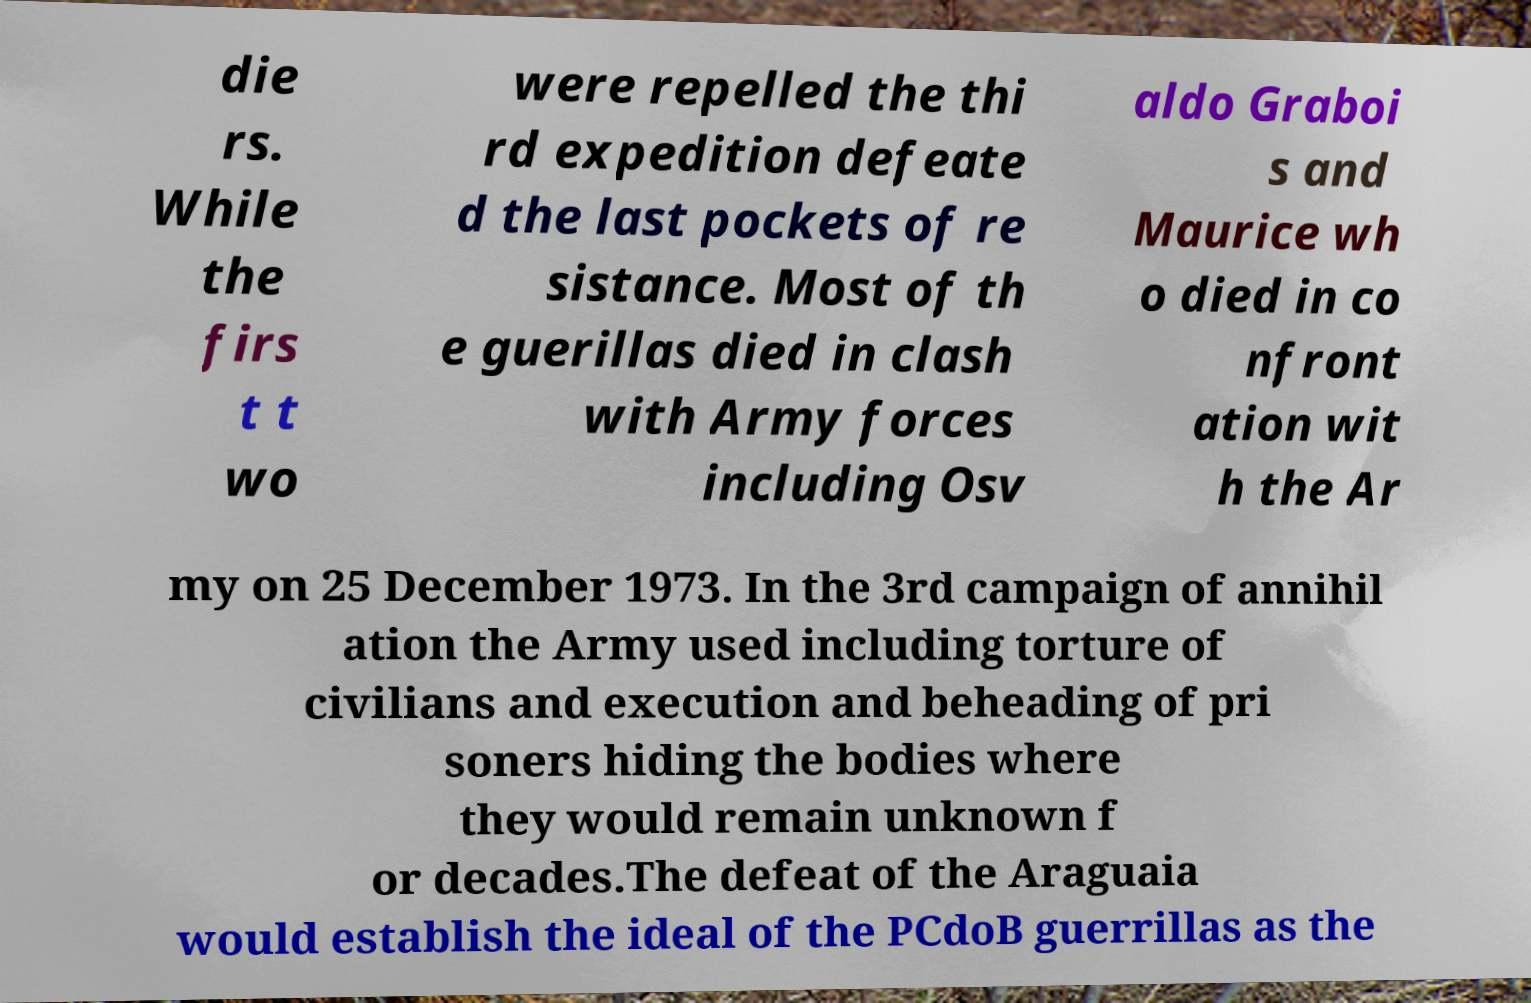There's text embedded in this image that I need extracted. Can you transcribe it verbatim? die rs. While the firs t t wo were repelled the thi rd expedition defeate d the last pockets of re sistance. Most of th e guerillas died in clash with Army forces including Osv aldo Graboi s and Maurice wh o died in co nfront ation wit h the Ar my on 25 December 1973. In the 3rd campaign of annihil ation the Army used including torture of civilians and execution and beheading of pri soners hiding the bodies where they would remain unknown f or decades.The defeat of the Araguaia would establish the ideal of the PCdoB guerrillas as the 